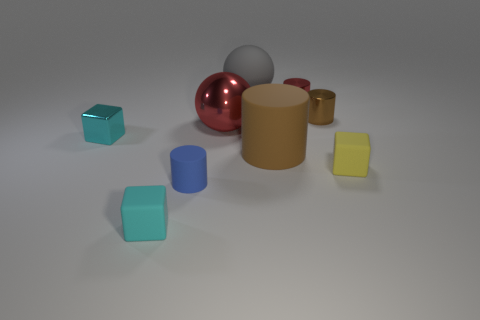Add 1 small brown metallic objects. How many objects exist? 10 Subtract all gray balls. How many balls are left? 1 Subtract all tiny matte blocks. How many blocks are left? 1 Subtract 3 cylinders. How many cylinders are left? 1 Subtract all blue balls. How many red blocks are left? 0 Subtract all large brown shiny balls. Subtract all large rubber spheres. How many objects are left? 8 Add 9 small metal cubes. How many small metal cubes are left? 10 Add 5 tiny brown rubber balls. How many tiny brown rubber balls exist? 5 Subtract 0 brown cubes. How many objects are left? 9 Subtract all spheres. How many objects are left? 7 